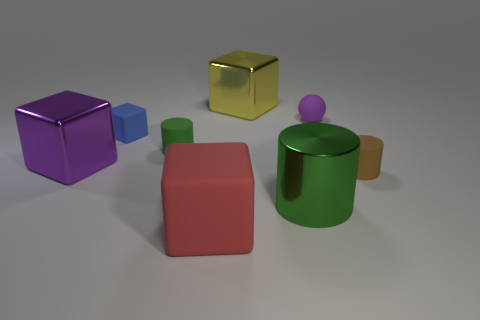How would you describe the composition of the geometric shapes in this image? The composition presents a variety of geometric shapes thoughtfully arranged in the space. They vary in color, size, and material, which creates visual interest. The shapes are spaced out in a manner that leads the eye across the image, with each form contributing to the overall balance and harmony of the scene. 